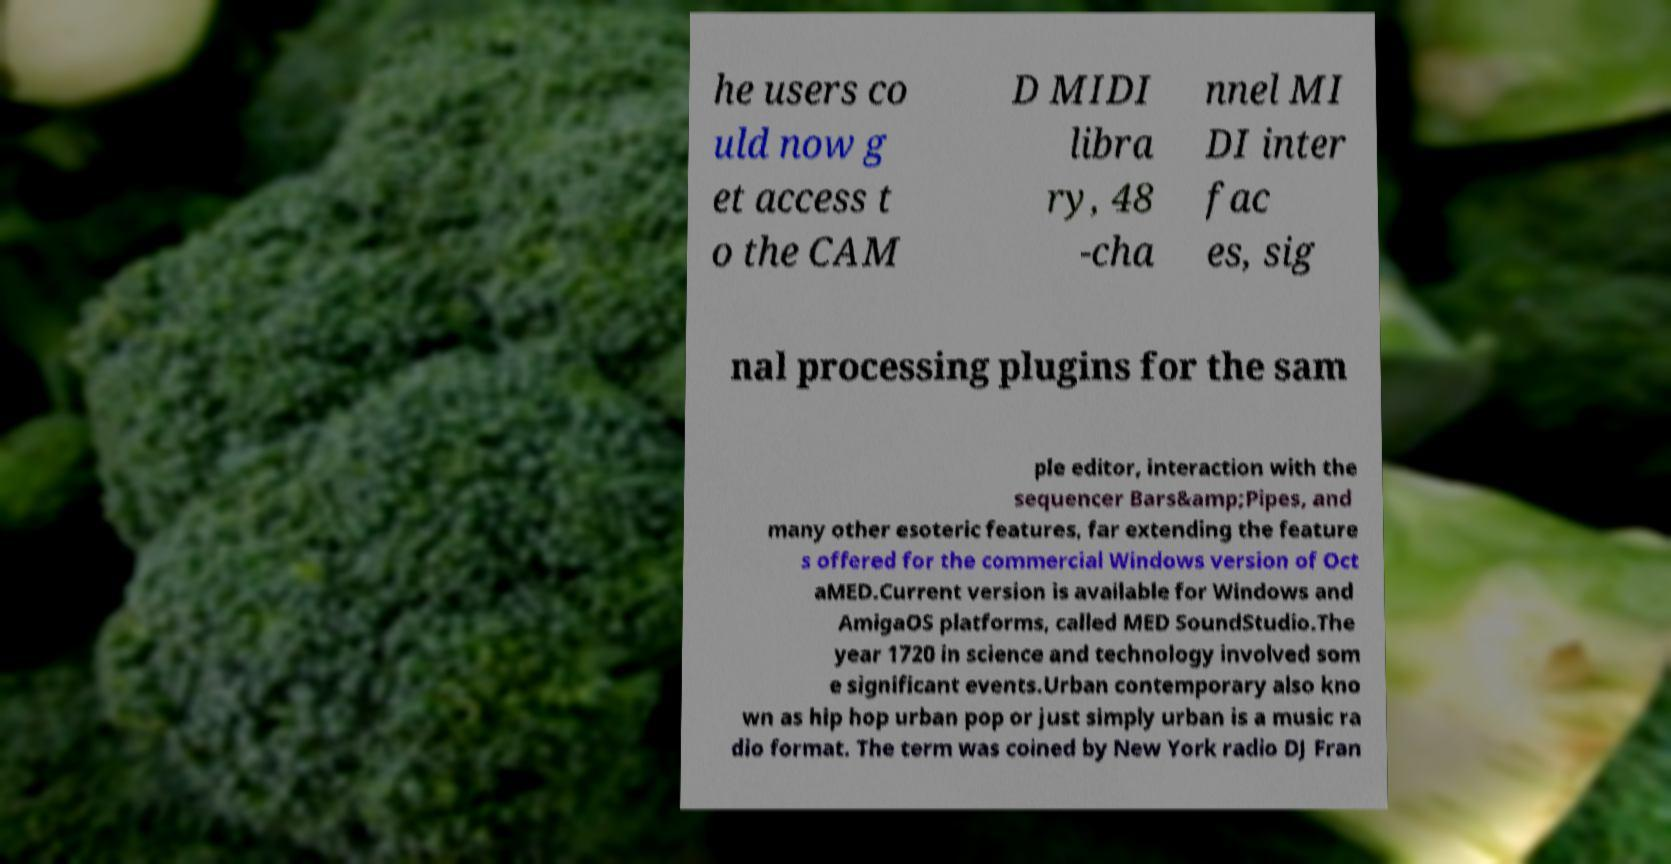Can you read and provide the text displayed in the image?This photo seems to have some interesting text. Can you extract and type it out for me? he users co uld now g et access t o the CAM D MIDI libra ry, 48 -cha nnel MI DI inter fac es, sig nal processing plugins for the sam ple editor, interaction with the sequencer Bars&amp;Pipes, and many other esoteric features, far extending the feature s offered for the commercial Windows version of Oct aMED.Current version is available for Windows and AmigaOS platforms, called MED SoundStudio.The year 1720 in science and technology involved som e significant events.Urban contemporary also kno wn as hip hop urban pop or just simply urban is a music ra dio format. The term was coined by New York radio DJ Fran 